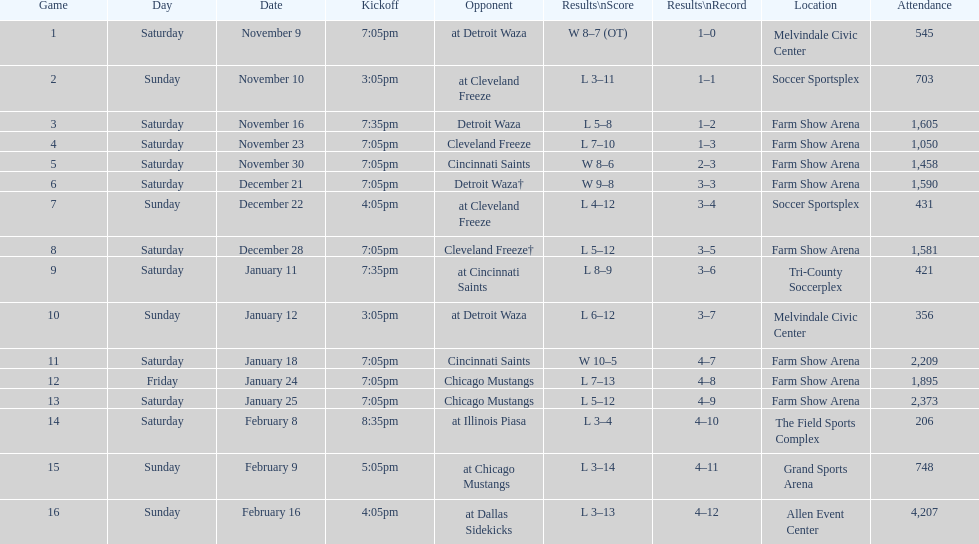Give me the full table as a dictionary. {'header': ['Game', 'Day', 'Date', 'Kickoff', 'Opponent', 'Results\\nScore', 'Results\\nRecord', 'Location', 'Attendance'], 'rows': [['1', 'Saturday', 'November 9', '7:05pm', 'at Detroit Waza', 'W 8–7 (OT)', '1–0', 'Melvindale Civic Center', '545'], ['2', 'Sunday', 'November 10', '3:05pm', 'at Cleveland Freeze', 'L 3–11', '1–1', 'Soccer Sportsplex', '703'], ['3', 'Saturday', 'November 16', '7:35pm', 'Detroit Waza', 'L 5–8', '1–2', 'Farm Show Arena', '1,605'], ['4', 'Saturday', 'November 23', '7:05pm', 'Cleveland Freeze', 'L 7–10', '1–3', 'Farm Show Arena', '1,050'], ['5', 'Saturday', 'November 30', '7:05pm', 'Cincinnati Saints', 'W 8–6', '2–3', 'Farm Show Arena', '1,458'], ['6', 'Saturday', 'December 21', '7:05pm', 'Detroit Waza†', 'W 9–8', '3–3', 'Farm Show Arena', '1,590'], ['7', 'Sunday', 'December 22', '4:05pm', 'at Cleveland Freeze', 'L 4–12', '3–4', 'Soccer Sportsplex', '431'], ['8', 'Saturday', 'December 28', '7:05pm', 'Cleveland Freeze†', 'L 5–12', '3–5', 'Farm Show Arena', '1,581'], ['9', 'Saturday', 'January 11', '7:35pm', 'at Cincinnati Saints', 'L 8–9', '3–6', 'Tri-County Soccerplex', '421'], ['10', 'Sunday', 'January 12', '3:05pm', 'at Detroit Waza', 'L 6–12', '3–7', 'Melvindale Civic Center', '356'], ['11', 'Saturday', 'January 18', '7:05pm', 'Cincinnati Saints', 'W 10–5', '4–7', 'Farm Show Arena', '2,209'], ['12', 'Friday', 'January 24', '7:05pm', 'Chicago Mustangs', 'L 7–13', '4–8', 'Farm Show Arena', '1,895'], ['13', 'Saturday', 'January 25', '7:05pm', 'Chicago Mustangs', 'L 5–12', '4–9', 'Farm Show Arena', '2,373'], ['14', 'Saturday', 'February 8', '8:35pm', 'at Illinois Piasa', 'L 3–4', '4–10', 'The Field Sports Complex', '206'], ['15', 'Sunday', 'February 9', '5:05pm', 'at Chicago Mustangs', 'L 3–14', '4–11', 'Grand Sports Arena', '748'], ['16', 'Sunday', 'February 16', '4:05pm', 'at Dallas Sidekicks', 'L 3–13', '4–12', 'Allen Event Center', '4,207']]} What was the location before tri-county soccerplex? Farm Show Arena. 